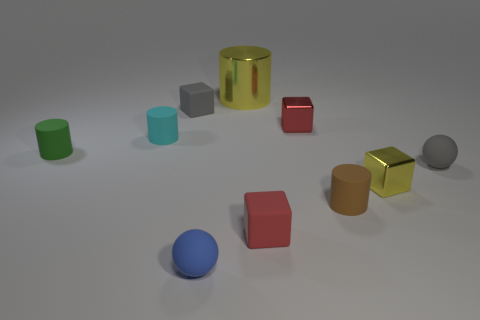Is there any other thing that has the same size as the metallic cylinder?
Ensure brevity in your answer.  No. What number of small yellow shiny objects are to the left of the small gray rubber sphere?
Your answer should be compact. 1. There is a gray object that is behind the gray object that is right of the large shiny thing; what is its material?
Give a very brief answer. Rubber. There is a yellow object that is the same size as the gray sphere; what material is it?
Provide a short and direct response. Metal. Is there a green thing that has the same size as the gray sphere?
Your answer should be compact. Yes. There is a matte ball left of the shiny cylinder; what is its color?
Provide a succinct answer. Blue. Are there any small rubber cylinders behind the cube that is left of the tiny blue thing?
Offer a terse response. No. How many other things are there of the same color as the shiny cylinder?
Provide a short and direct response. 1. Do the matte ball that is behind the brown object and the green cylinder left of the small gray cube have the same size?
Offer a terse response. Yes. There is a matte thing behind the small shiny thing that is on the left side of the tiny yellow metallic block; how big is it?
Ensure brevity in your answer.  Small. 